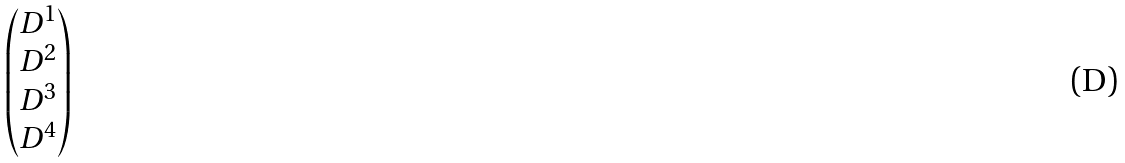<formula> <loc_0><loc_0><loc_500><loc_500>\begin{pmatrix} D ^ { 1 } \\ D ^ { 2 } \\ D ^ { 3 } \\ D ^ { 4 } \end{pmatrix}</formula> 